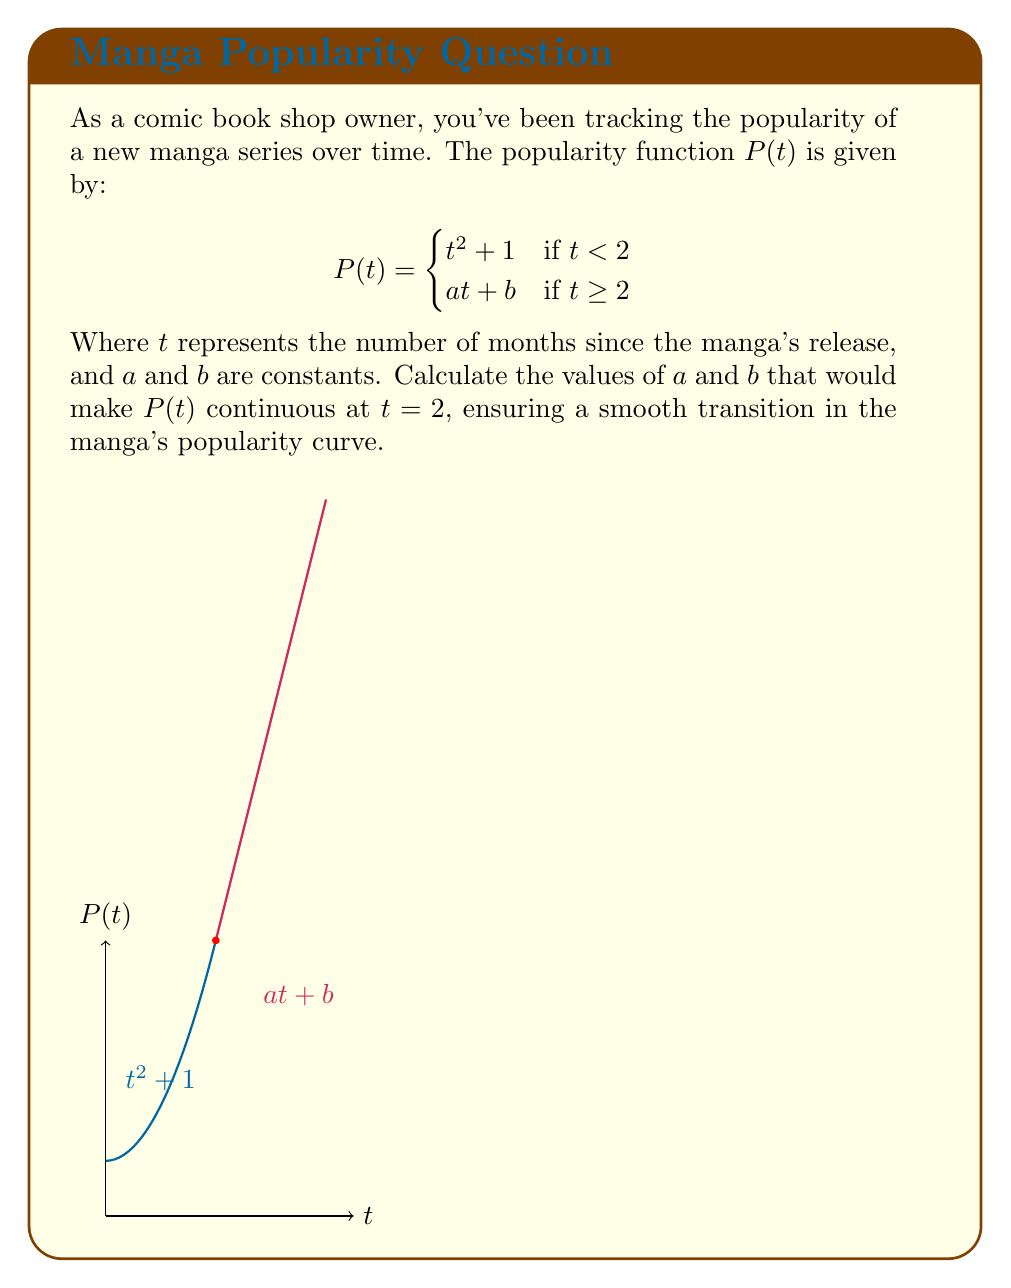Can you solve this math problem? To ensure continuity at $t = 2$, we need to satisfy two conditions:

1) The limit of $P(t)$ as $t$ approaches 2 from both sides must be equal.
2) The function value at $t = 2$ must equal this limit.

Step 1: Calculate $\lim_{t \to 2^-} P(t)$
$$\lim_{t \to 2^-} P(t) = \lim_{t \to 2^-} (t^2 + 1) = 2^2 + 1 = 5$$

Step 2: Set up the equation for the right-hand limit
$$\lim_{t \to 2^+} P(t) = \lim_{t \to 2^+} (at + b) = 2a + b$$

Step 3: Equate the limits
$$2a + b = 5$$

Step 4: Use the function value at $t = 2$
$$P(2) = 2a + b = 5$$

Step 5: Calculate the derivative of $t^2 + 1$ at $t = 2$
$$\frac{d}{dt}(t^2 + 1) = 2t$$
At $t = 2$, this equals 4.

Step 6: For smoothness, set $a$ equal to this derivative
$$a = 4$$

Step 7: Solve for $b$ using the equation from Step 3
$$2(4) + b = 5$$
$$8 + b = 5$$
$$b = -3$$

Therefore, $a = 4$ and $b = -3$.
Answer: $a = 4, b = -3$ 